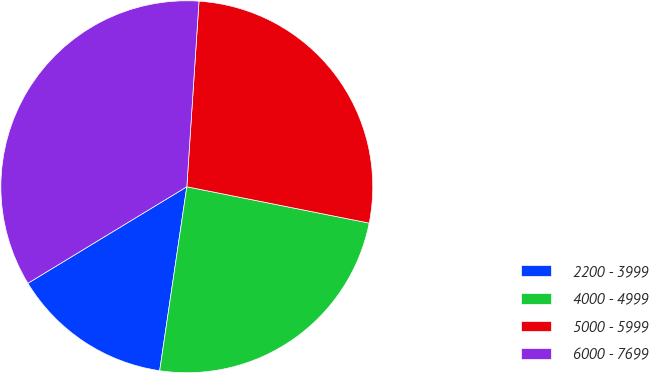<chart> <loc_0><loc_0><loc_500><loc_500><pie_chart><fcel>2200 - 3999<fcel>4000 - 4999<fcel>5000 - 5999<fcel>6000 - 7699<nl><fcel>13.98%<fcel>24.2%<fcel>27.09%<fcel>34.73%<nl></chart> 